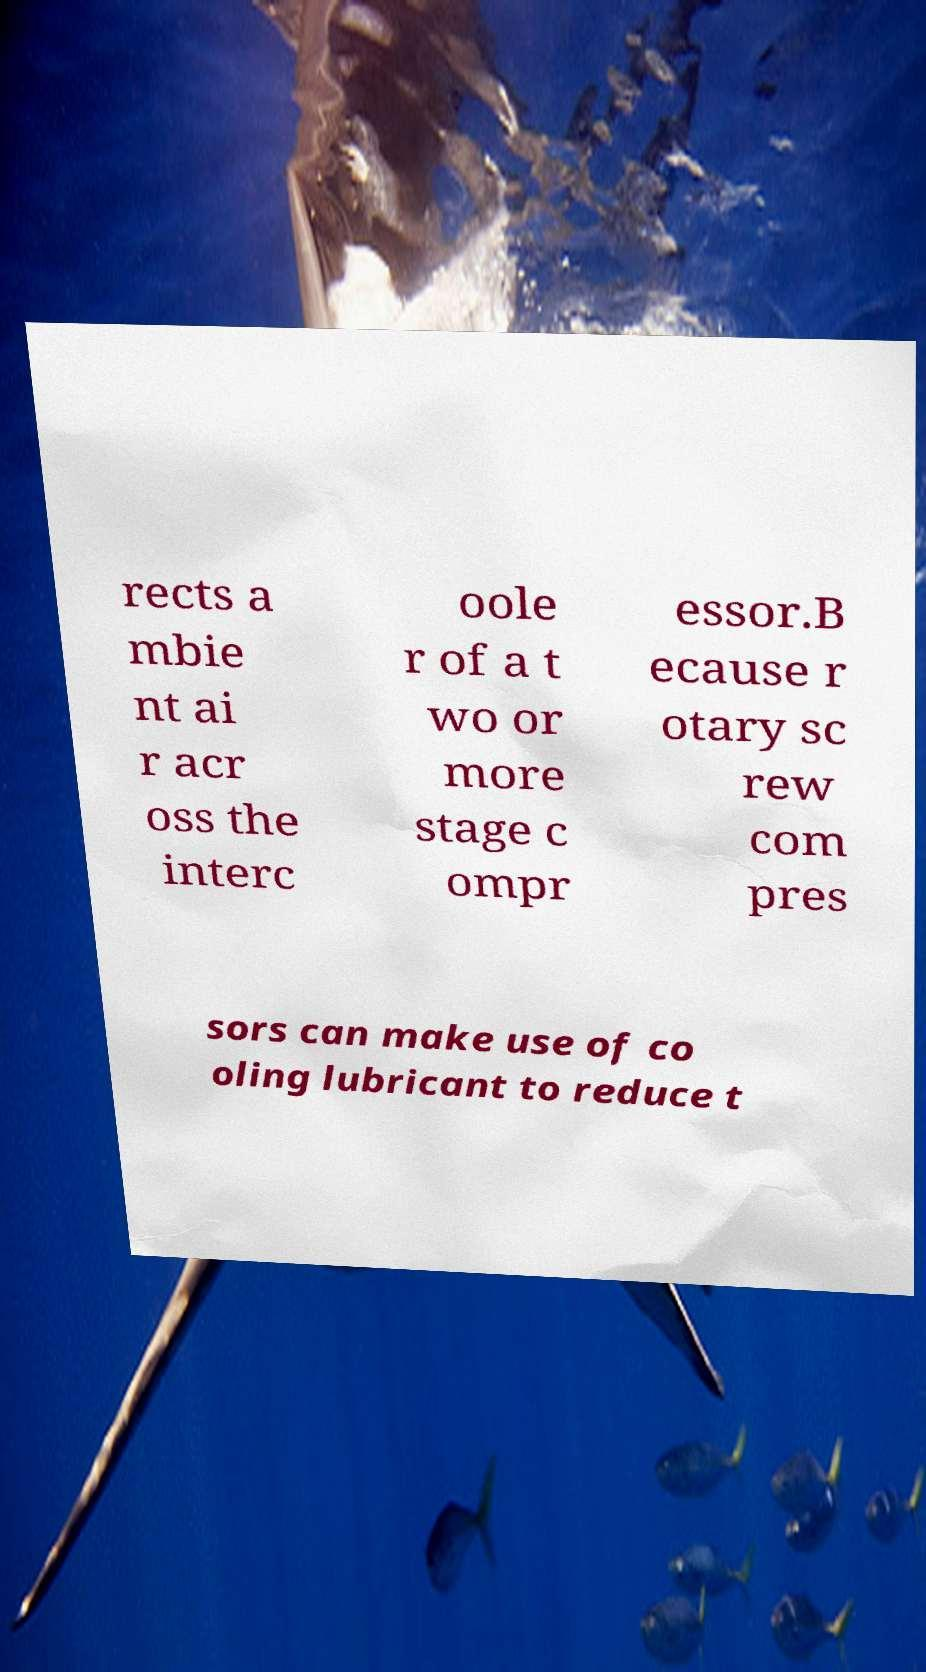Could you assist in decoding the text presented in this image and type it out clearly? rects a mbie nt ai r acr oss the interc oole r of a t wo or more stage c ompr essor.B ecause r otary sc rew com pres sors can make use of co oling lubricant to reduce t 